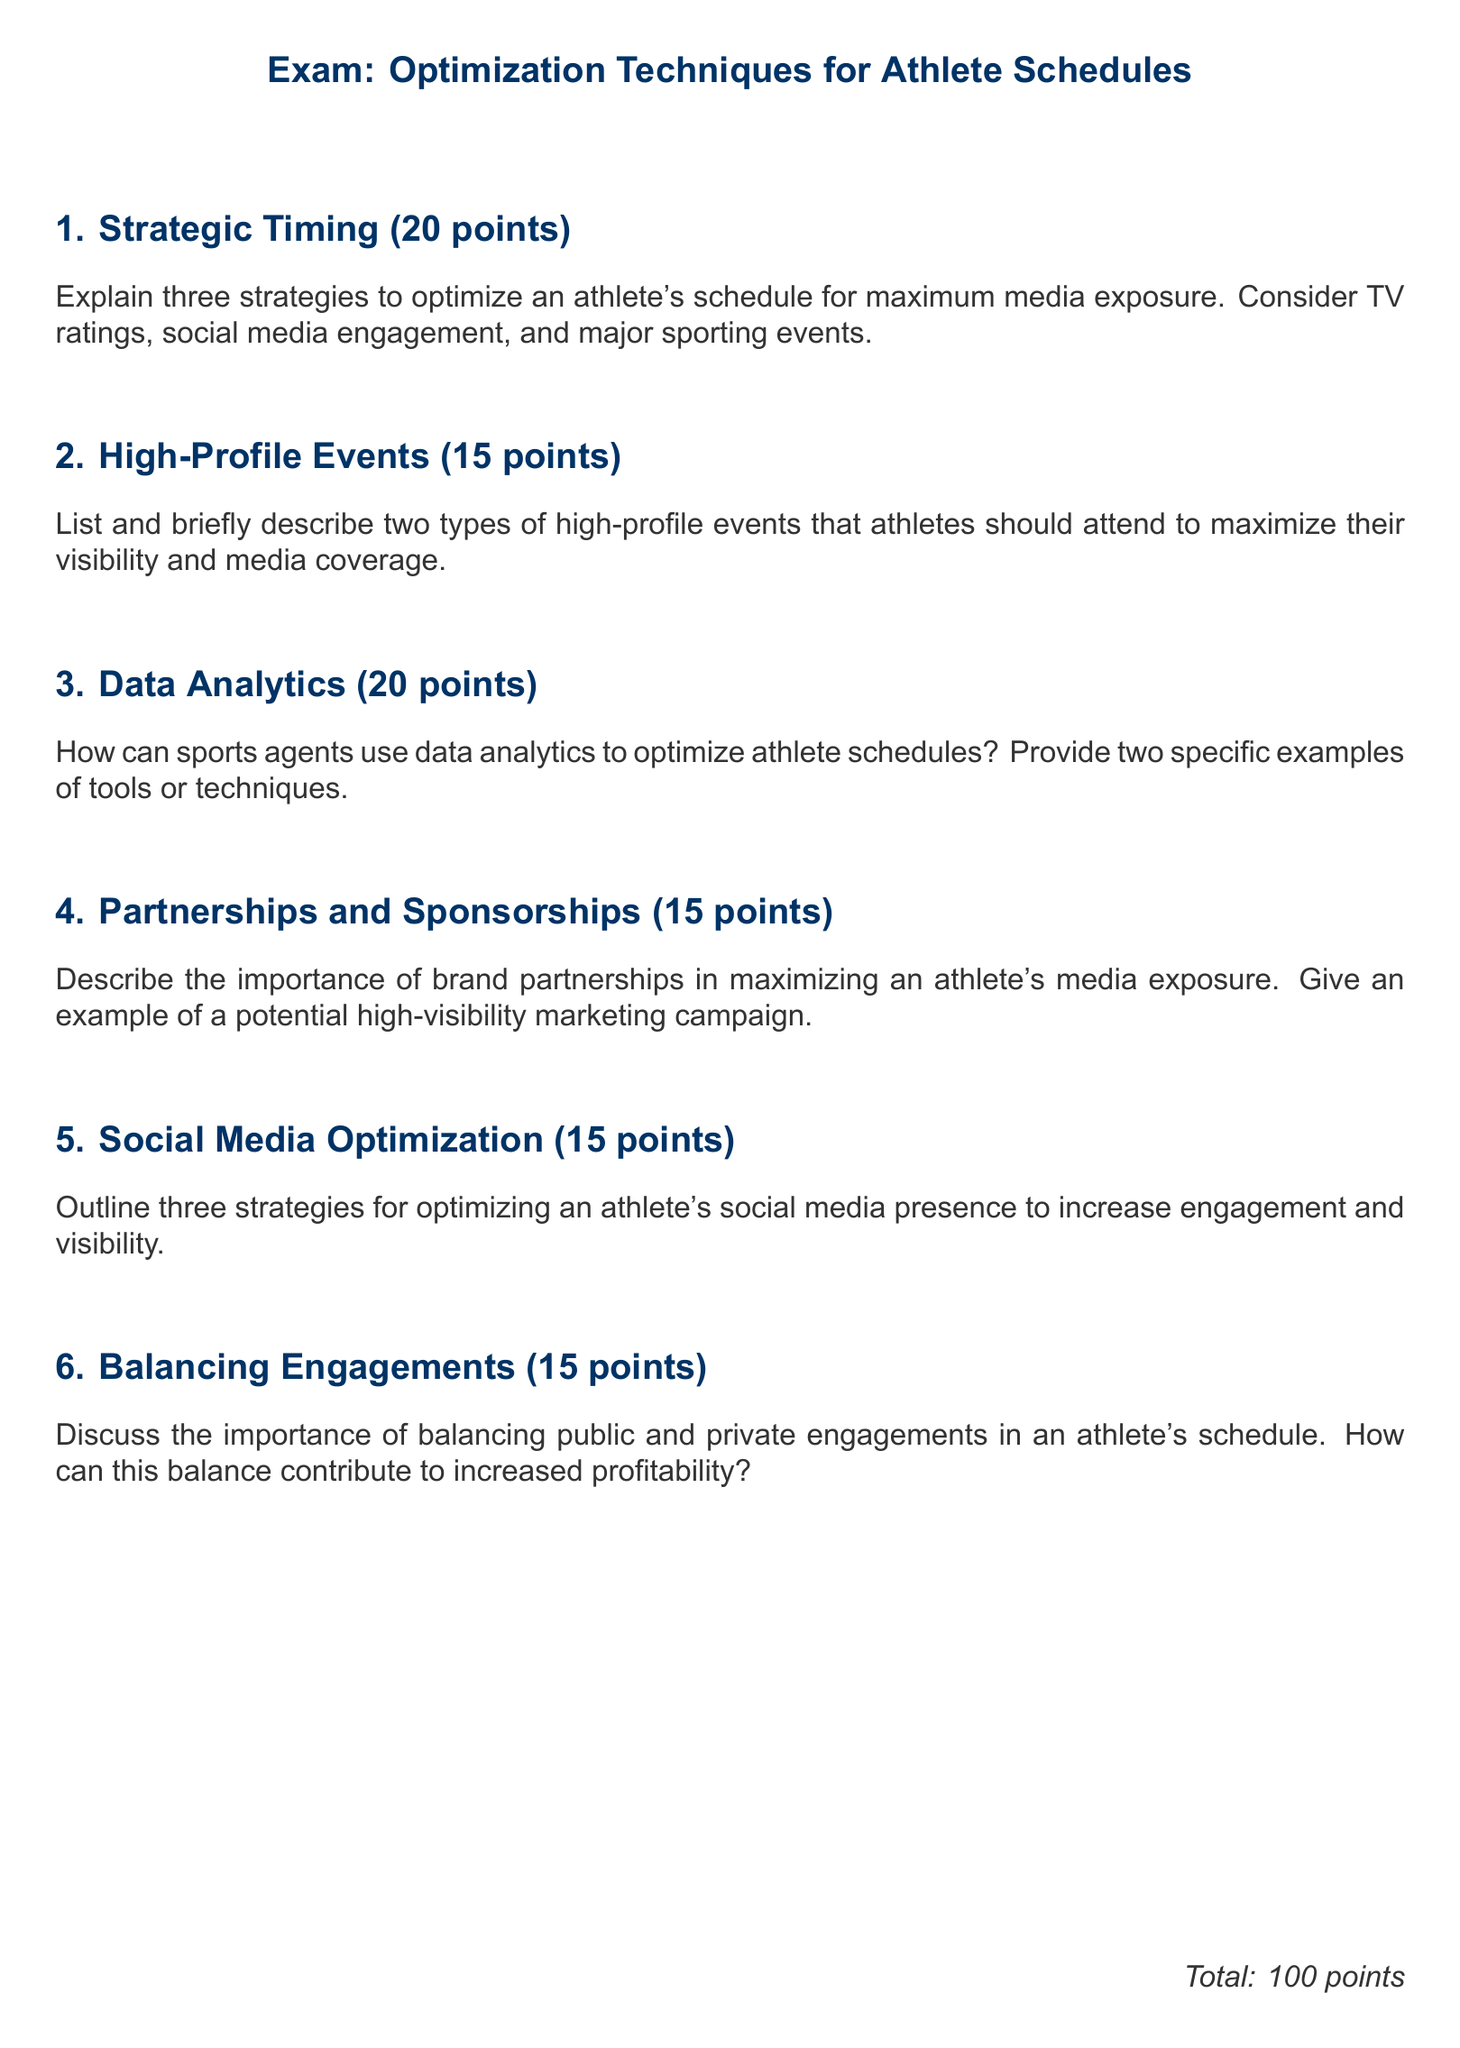What is the total number of points for the exam? The total points for the exam are stated clearly at the end of the document.
Answer: 100 points What is one area to optimize for maximum media exposure? The document specifically mentions TV ratings as a key area to consider for optimizing athlete schedules.
Answer: TV ratings How many types of high-profile events should athletes attend according to the document? The document instructs to describe two types of high-profile events, indicating there are two mentioned.
Answer: Two What is one tool or technique mentioned for data analytics in optimizing athlete schedules? The document asks for specific examples and suggests that tools or techniques related to data analytics be provided, but does not specify them, so the answer is general.
Answer: Data analytics tool What section discusses the importance of brand partnerships? The document has a specific section dedicated to brand partnerships and their significance in media exposure.
Answer: Partnerships and Sponsorships How many strategies should be outlined for optimizing an athlete's social media presence? The document requests three strategies to be outlined for this purpose.
Answer: Three What is the focus of the exam as highlighted in its title? The title of the exam clearly indicates its primary focus area which is optimization techniques for athlete schedules.
Answer: Optimization Techniques for Athlete Schedules 